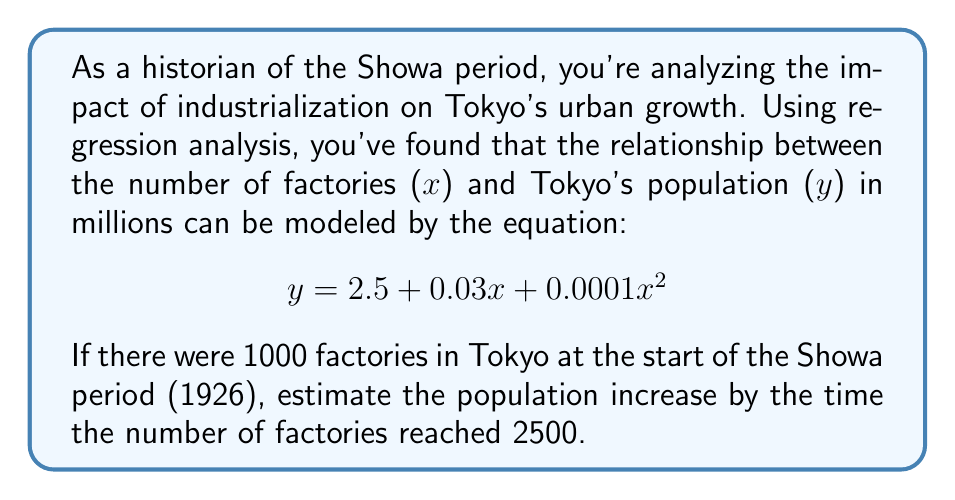Show me your answer to this math problem. To solve this problem, we'll follow these steps:

1) Calculate the population when there were 1000 factories:
   $$ y_1 = 2.5 + 0.03(1000) + 0.0001(1000)^2 $$
   $$ y_1 = 2.5 + 30 + 100 = 132.5 \text{ million} $$

2) Calculate the population when there were 2500 factories:
   $$ y_2 = 2.5 + 0.03(2500) + 0.0001(2500)^2 $$
   $$ y_2 = 2.5 + 75 + 625 = 702.5 \text{ million} $$

3) Calculate the difference to find the population increase:
   $$ \text{Increase} = y_2 - y_1 = 702.5 - 132.5 = 570 \text{ million} $$

This large increase might seem unrealistic for Tokyo, but remember this is a simplified model and actual population growth would be influenced by many other factors not accounted for in this equation.
Answer: 570 million 